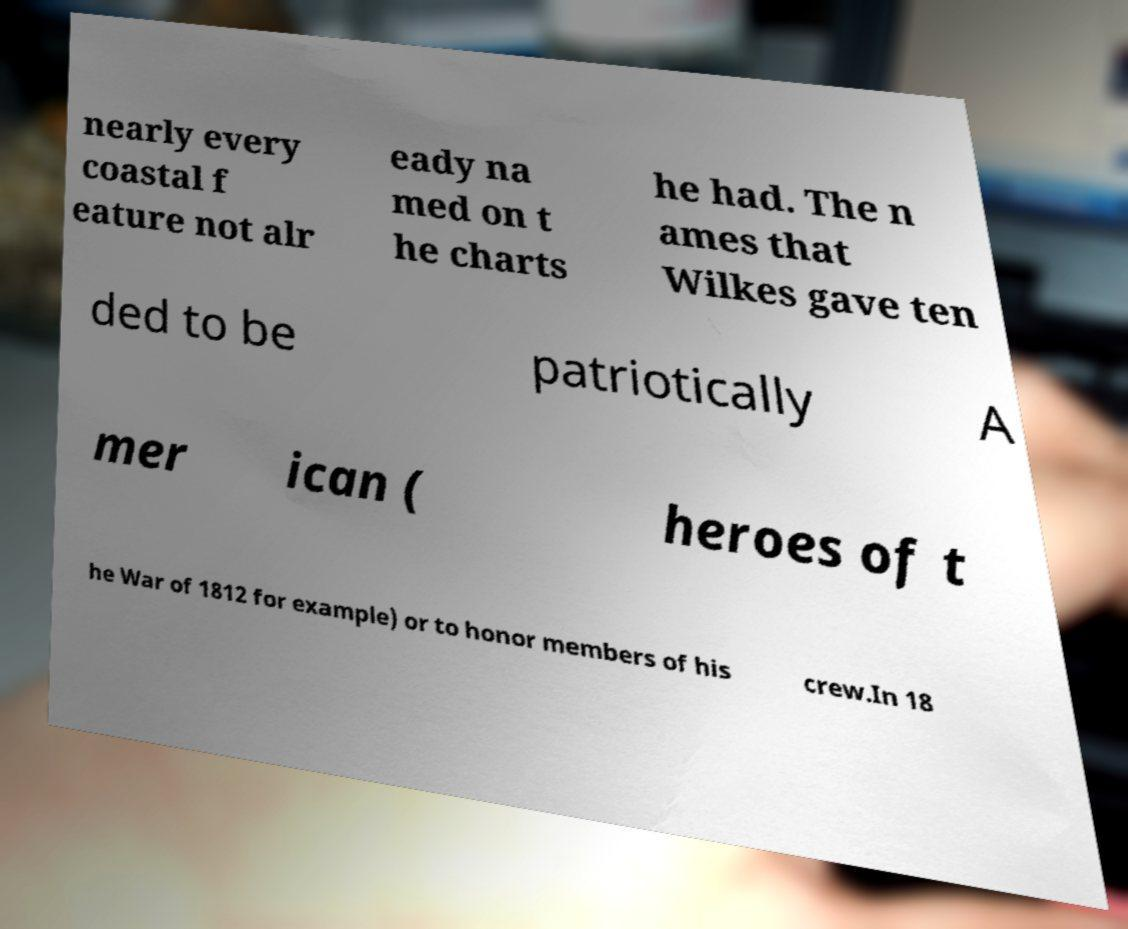Please identify and transcribe the text found in this image. nearly every coastal f eature not alr eady na med on t he charts he had. The n ames that Wilkes gave ten ded to be patriotically A mer ican ( heroes of t he War of 1812 for example) or to honor members of his crew.In 18 